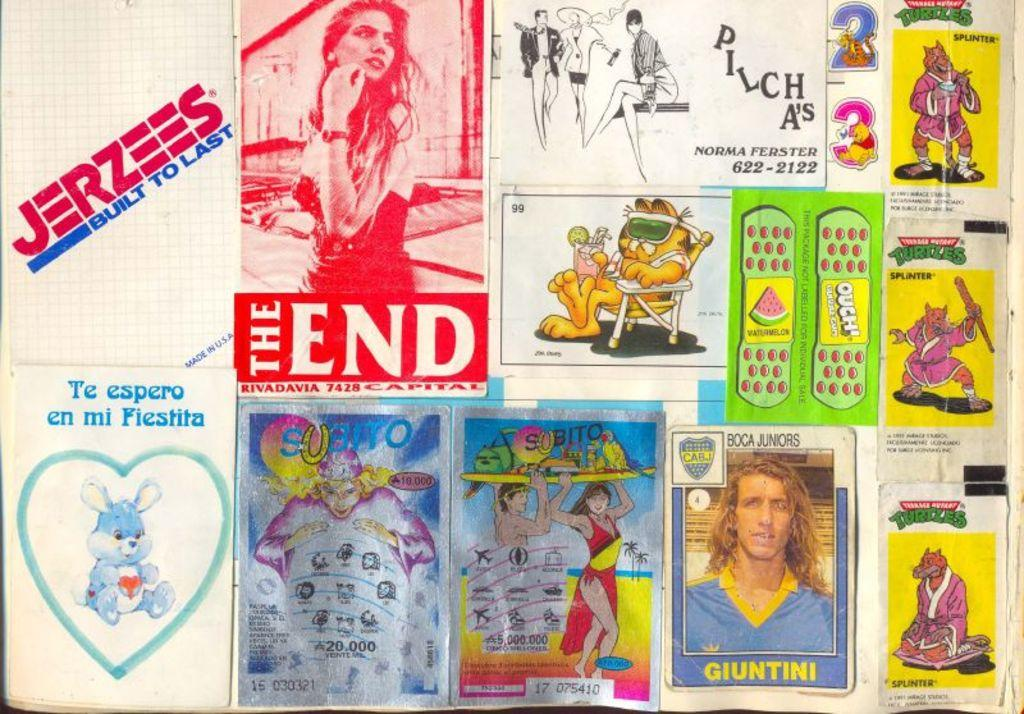What type of visual is the image? The image is a poster. What kind of characters are depicted in the poster? There are cartoons in the image. Are there any words or phrases in the poster? Yes, there is text in the image. How does the light affect the cartoons in the image? There is no mention of light in the image, so we cannot determine its effect on the cartoons. 